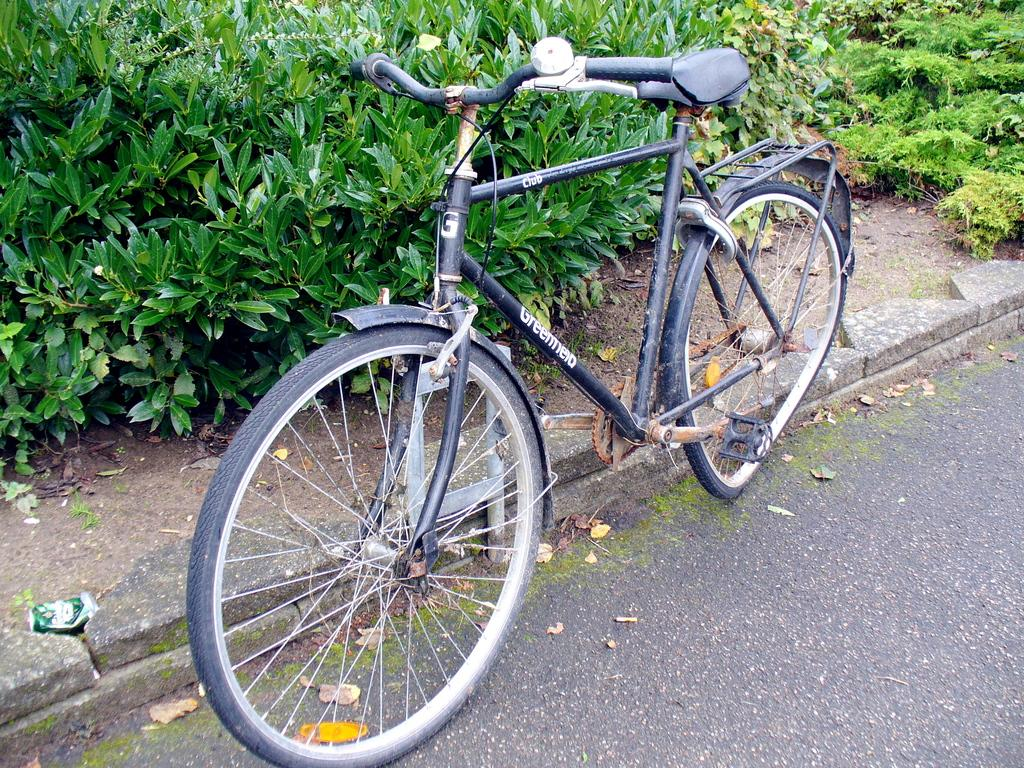What is the main object in the image? There is a bicycle in the image. Where is the bicycle located? The bicycle is parked on the road. What can be seen in the background of the image? There are plants visible in the background of the image. What is on the ground on the left side of the image? There is a tin on the ground on the left side of the image. How many cats are sitting on the bicycle in the image? There are no cats present in the image; it only features a bicycle, plants in the background, and a tin on the ground. 